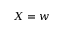Convert formula to latex. <formula><loc_0><loc_0><loc_500><loc_500>X = w</formula> 